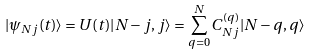<formula> <loc_0><loc_0><loc_500><loc_500>| \psi _ { N j } ( t ) \rangle = U ( t ) | N - j , j \rangle = \sum _ { q = 0 } ^ { N } C ^ { ( q ) } _ { N j } | N - q , q \rangle</formula> 